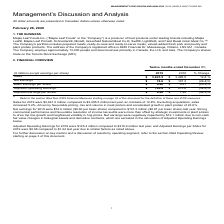Looking at Maple Leaf Foods's financial data, please calculate: What is the net earnings per worker in 2019? Based on the calculation: 74.6/13,000, the result is 0.01 (in millions). This is based on the information: "Net Earnings $ 74.6 $ 101.3 (26.4)% 5N 0A1, Canada. The Company employs approximately 13,000 people and does business primarily in Canada, the U.S. and Asia. The Company's shares trade on the 5N 0A1, ..." The key data points involved are: 13,000, 74.6. Also, Why did sales increase in 2019? Driven by favourable pricing, mix and volume in meat protein and accelerated growth in plant protein. The document states: "8%. Excluding acquisitions, sales increased 5.2%, driven by favourable pricing, mix and volume in meat protein and accelerated growth in plant protein..." Also, can you calculate: How much are the expenses in 2019? Based on the calculation: 3,941.5-74.6, the result is 3866.9 (in millions). This is based on the information: "Sales $ 3,941.5 $ 3,495.5 12.8 % Net Earnings $ 74.6 $ 101.3 (26.4)%..." The key data points involved are: 3,941.5, 74.6. Also, Why did net earnings fall in 2019? Strategic investments in plant protein to drive top line growth and heightened volatility in hog prices.. The document states: "tion of income tax audits were more than offset by strategic investments in plant protein to drive top line growth and heightened volatility in hog pr..." Also, How are acquisitions calculated in change of sales? Excluding acquisitions, sales increased. The document states: "$3,495.5 million last year, an increase of 12.8%. Excluding acquisitions, sales increased 5.2%, driven by favourable pricing, mix and volume in meat p..." Also, can you calculate: How many outstanding shares does the company has in 2019? Based on the calculation: 74.6/0.6, the result is 124.33 (in millions). This is based on the information: "Basic Earnings per Share $ 0.60 $ 0.81 (25.9)% Net Earnings $ 74.6 $ 101.3 (26.4)%..." The key data points involved are: 0.6, 74.6. 